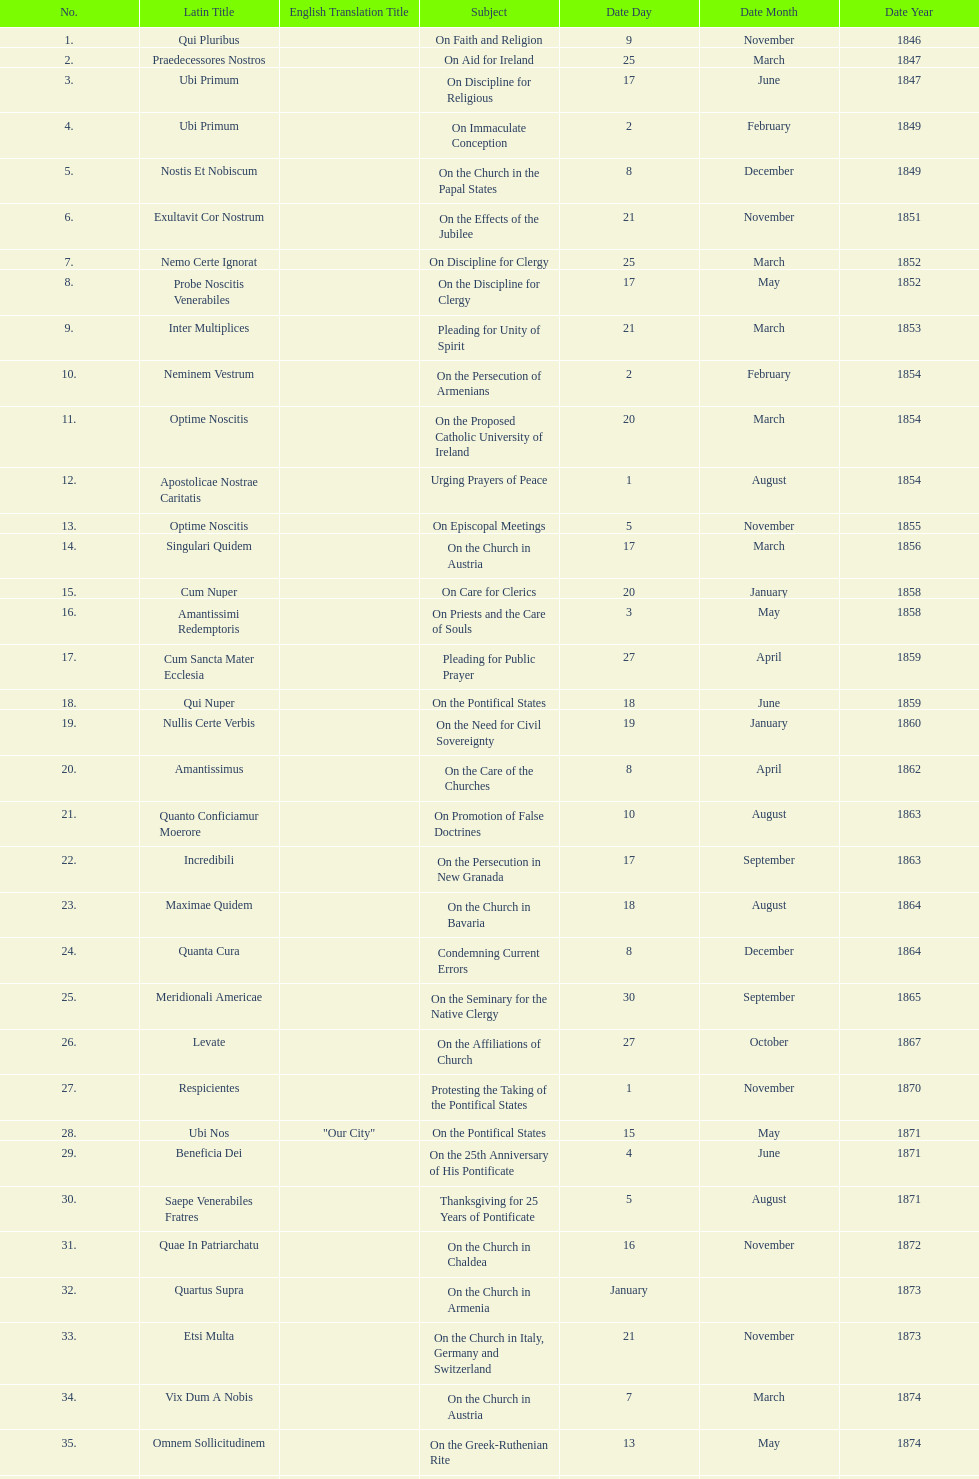How many encyclicals were issued between august 15, 1854 and october 26, 1867? 13. 